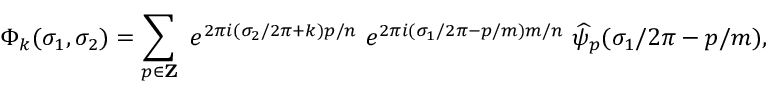<formula> <loc_0><loc_0><loc_500><loc_500>\Phi _ { k } ( \sigma _ { 1 } , \sigma _ { 2 } ) = \sum _ { p \in { Z } } e ^ { 2 \pi i ( \sigma _ { 2 } / 2 \pi + k ) p / n } e ^ { 2 \pi i ( \sigma _ { 1 } / 2 \pi - p / m ) m / n } \widehat { \psi } _ { p } ( \sigma _ { 1 } / 2 \pi - p / m ) ,</formula> 